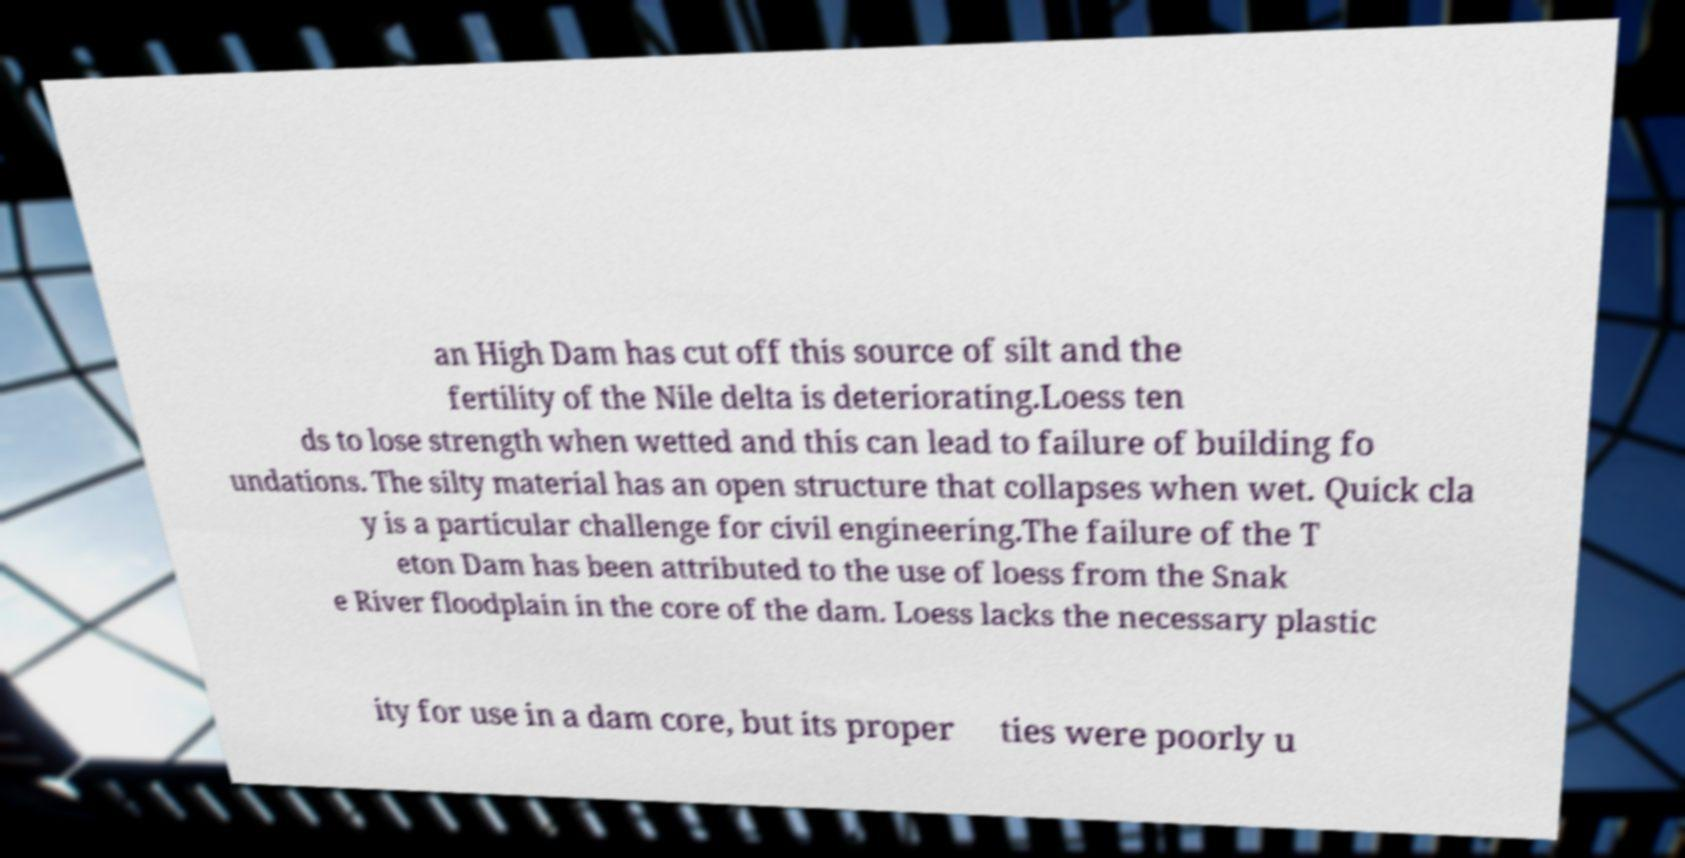What messages or text are displayed in this image? I need them in a readable, typed format. an High Dam has cut off this source of silt and the fertility of the Nile delta is deteriorating.Loess ten ds to lose strength when wetted and this can lead to failure of building fo undations. The silty material has an open structure that collapses when wet. Quick cla y is a particular challenge for civil engineering.The failure of the T eton Dam has been attributed to the use of loess from the Snak e River floodplain in the core of the dam. Loess lacks the necessary plastic ity for use in a dam core, but its proper ties were poorly u 